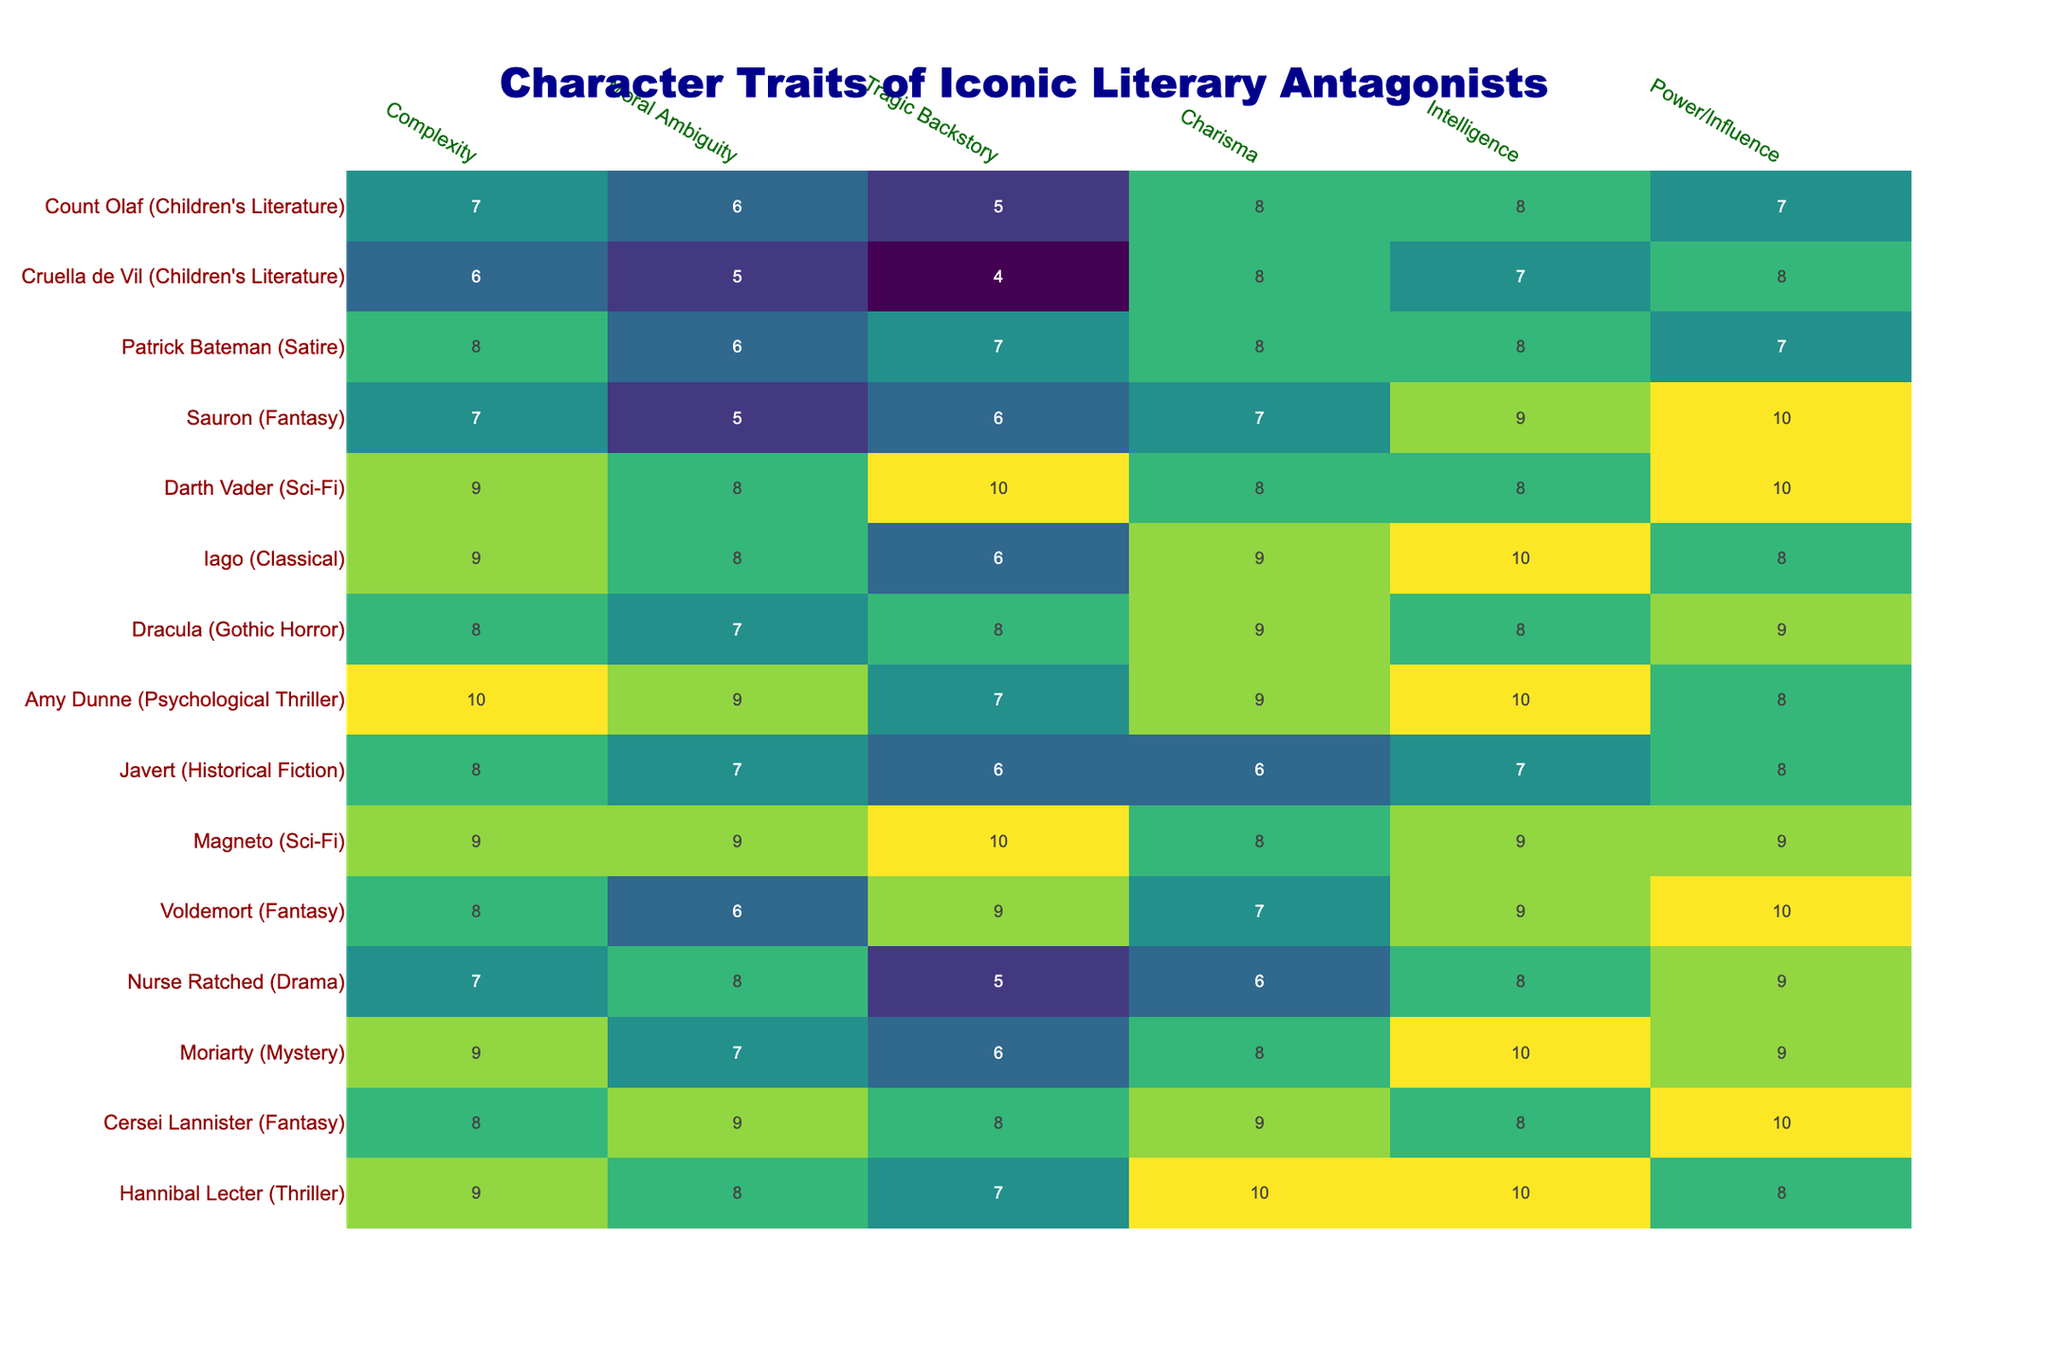What character has the highest complexity rating? By inspecting the complexity ratings of all characters, we find that Amy Dunne has the highest rating of 10.
Answer: Amy Dunne Which antagonist has the lowest power/influence score? Looking at the power/influence column, Cruella de Vil has the lowest score of 6.
Answer: Cruella de Vil What is the average moral ambiguity score of all characters listed? First, we sum the moral ambiguity scores (8 + 9 + 7 + 8 + 6 + 9 + 7 + 9 + 7 + 8 + 8 + 6) = 99. There are 12 characters, so we divide 99 by 12 to get an average of 8.25.
Answer: 8.25 Is there a character who has both the highest charisma and intelligence scores? By checking the charisma and intelligence scores, Hannibal Lecter has both the highest charisma (10) and intelligence (10).
Answer: Yes Which antagonist has the highest intelligence and what is that score? The antagonist with the highest intelligence score is Moriarty, who has a score of 10.
Answer: Moriarty, 10 What is the range of the tragic backstory scores? The highest tragic backstory score is 10 (Magneto) and the lowest is 5 (Nurse Ratched and Count Olaf), giving a range of 10 - 5 = 5.
Answer: 5 Are there any characters with identical moral ambiguity scores? Yes, Cersei Lannister and Iago both have a moral ambiguity score of 9.
Answer: Yes Calculate the difference in complexity scores between the highest and lowest rated characters. The highest complexity score is 10 (Amy Dunne), and the lowest is 6 (Cruella de Vil), so the difference is 10 - 6 = 4.
Answer: 4 Which two characters have a combination of both high charisma and power/influence? By examining the scores, Hannibal Lecter (10 charisma, 8 power) and Cersei Lannister (9 charisma, 10 power) both show strong charisma and power/influence.
Answer: Hannibal Lecter and Cersei Lannister What is the total score for intelligence and complexity of Voldemort? Voldemort has a complexity score of 8 and an intelligence score of 9, so the total is 8 + 9 = 17.
Answer: 17 